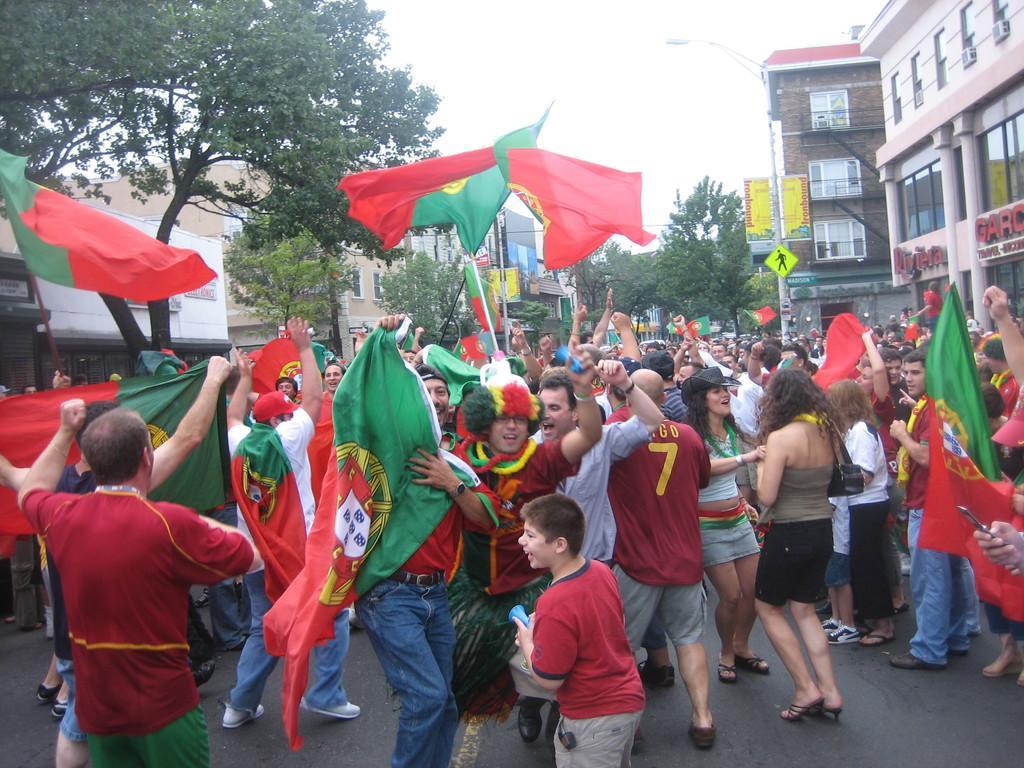How would you summarize this image in a sentence or two? In this image I can see number of persons are standing on the ground and holding few flags which are red and green in color. In the background I can see few trees, few poles, few boards, few buildings and the sky. 